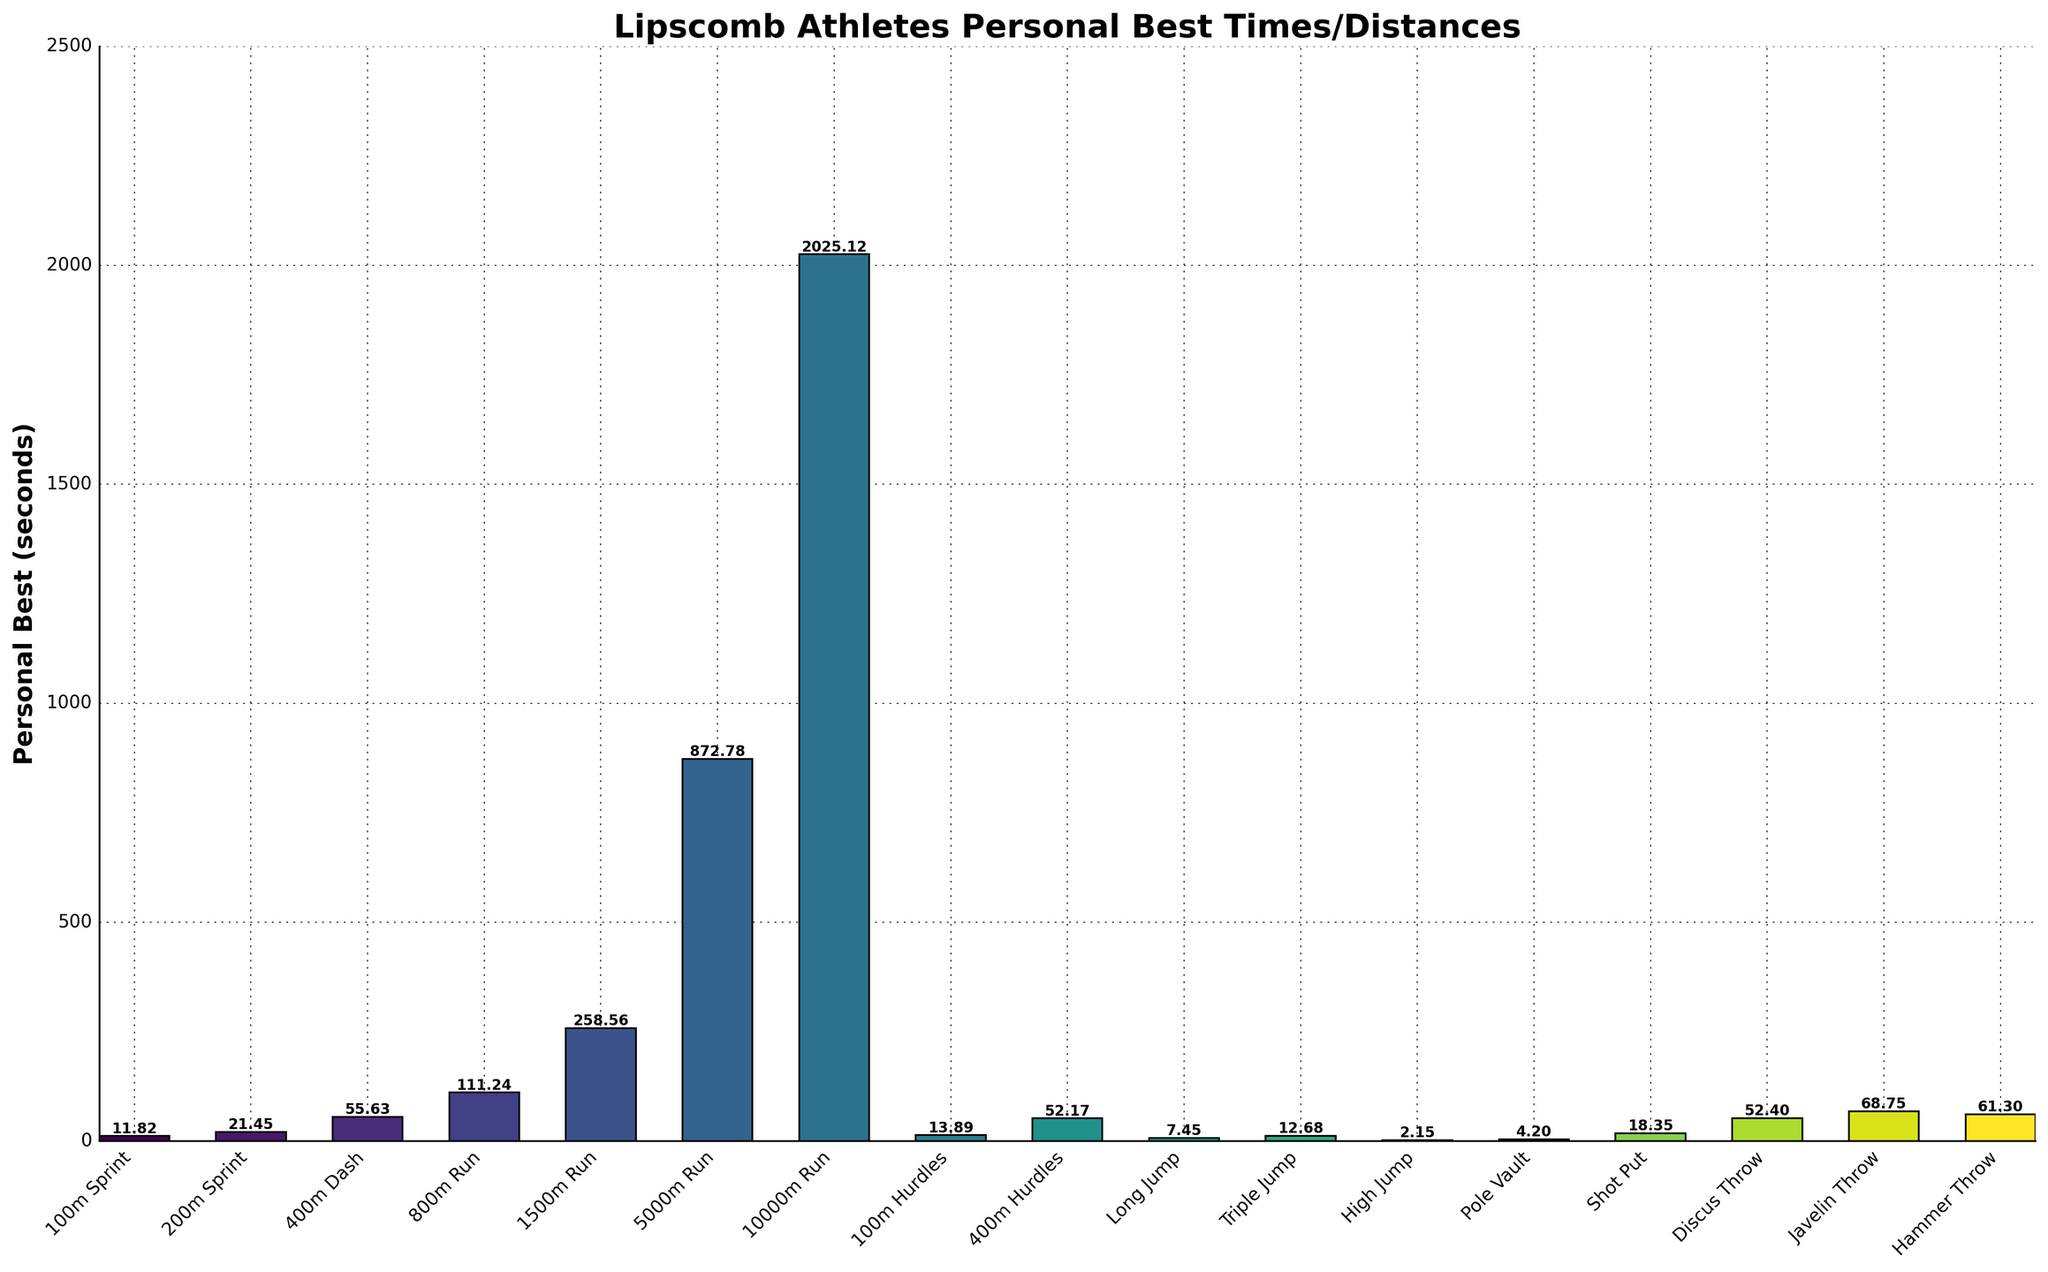Which event has the fastest personal best time? The fastest personal best is indicated by the shortest bar. The 100m Sprint appears to have the shortest bar, suggesting the fastest time.
Answer: 100m Sprint Which event has the longest personal best time or distance? The event with the longest personal best time or distance is represented by the highest bar. The Hammer Throw has the highest bar among all events.
Answer: Hammer Throw What is the difference in personal best times between the 100m Sprint and the 800m Run? The 100m Sprint has a personal best of 11.82 seconds and the 800m Run has a personal best of 1:51.24. Converting 1:51.24 to seconds (1*60 + 51.24 = 111.24) and then subtracting 11.82 from 111.24 gives 111.24 - 11.82 = 99.42 seconds.
Answer: 99.42 seconds Which athlete has the second fastest personal best time in their event, based on the figure? Refer to the second shortest bar. The second shortest bar belongs to Olivia Martinez in the 100m Hurdles with a time of 13.89 seconds.
Answer: Olivia Martinez How many events have personal bests below 60 seconds? Identify bars representing times under 60 seconds. Events with times below 60 seconds are: 100m Sprint (11.82), 200m Sprint (21.45), 400m Dash (55.63), and 100m Hurdles (13.89). There are 4 such events.
Answer: 4 events What is the average personal best time for the Sprint events (100m, 200m, 400m)? The personal best times for the three Sprint events are: 100m Sprint (11.82 seconds), 200m Sprint (21.45 seconds), 400m Dash (55.63 seconds). The sum is 11.82 + 21.45 + 55.63 = 88.90 seconds. Dividing by 3 gives 88.90 / 3 = 29.63 seconds.
Answer: 29.63 seconds What is the median personal best time for all the running events? Sort the personal best times for the running events: 100m Sprint (11.82), 200m Sprint (21.45), 400m Dash (55.63), 800m Run (1:51.24 = 111.24), 1500m Run (278.56), 5000m Run (872.78), 10000m Run (2025.12), 100m Hurdles (13.89), 400m Hurdles (52.17). The sorted times are: 11.82, 13.89, 21.45, 52.17, 55.63, 111.24, 278.56, 872.78, 2025.12. The median is the middle value, 55.63.
Answer: 55.63 seconds Compare the personal best time for the 100m Hurdles and the number of events under 60 seconds. The personal best time for the 100m Hurdles is 13.89 seconds, and there are 4 events under 60 seconds. Identifying and comparing these values show simplicity in evaluating them visually on the graph.
Answer: 13.89 seconds and 4 events Which throwing event has the shortest personal best distance? Among the throwing events (Shot Put, Discus Throw, Javelin Throw, Hammer Throw), identify the shortest bar. The Shot Put with a personal best of 18.35 meters is the shortest among these.
Answer: Shot Put Which event shows a personal best time that is closest to 1 minute? Look for a bar with a height closest to 60 seconds. The 400m Dash with a personal best of 55.63 seconds is closest to 1 minute.
Answer: 400m Dash 